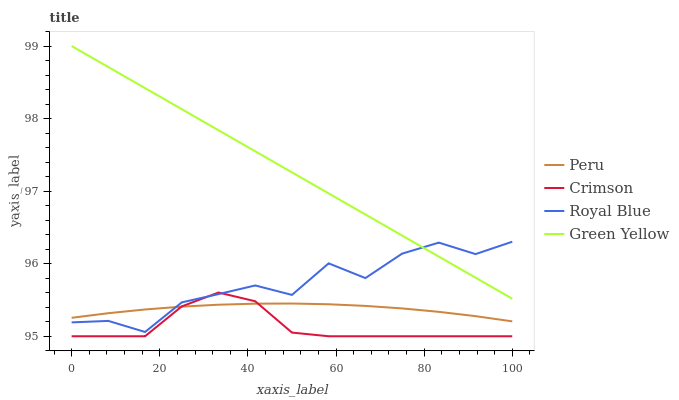Does Crimson have the minimum area under the curve?
Answer yes or no. Yes. Does Green Yellow have the maximum area under the curve?
Answer yes or no. Yes. Does Royal Blue have the minimum area under the curve?
Answer yes or no. No. Does Royal Blue have the maximum area under the curve?
Answer yes or no. No. Is Green Yellow the smoothest?
Answer yes or no. Yes. Is Royal Blue the roughest?
Answer yes or no. Yes. Is Royal Blue the smoothest?
Answer yes or no. No. Is Green Yellow the roughest?
Answer yes or no. No. Does Crimson have the lowest value?
Answer yes or no. Yes. Does Royal Blue have the lowest value?
Answer yes or no. No. Does Green Yellow have the highest value?
Answer yes or no. Yes. Does Royal Blue have the highest value?
Answer yes or no. No. Is Peru less than Green Yellow?
Answer yes or no. Yes. Is Green Yellow greater than Peru?
Answer yes or no. Yes. Does Peru intersect Royal Blue?
Answer yes or no. Yes. Is Peru less than Royal Blue?
Answer yes or no. No. Is Peru greater than Royal Blue?
Answer yes or no. No. Does Peru intersect Green Yellow?
Answer yes or no. No. 